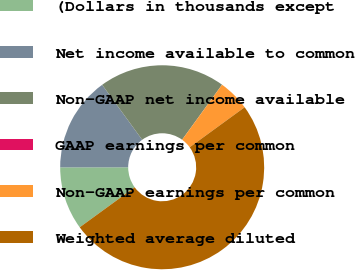<chart> <loc_0><loc_0><loc_500><loc_500><pie_chart><fcel>(Dollars in thousands except<fcel>Net income available to common<fcel>Non-GAAP net income available<fcel>GAAP earnings per common<fcel>Non-GAAP earnings per common<fcel>Weighted average diluted<nl><fcel>10.0%<fcel>15.0%<fcel>20.0%<fcel>0.0%<fcel>5.0%<fcel>50.0%<nl></chart> 